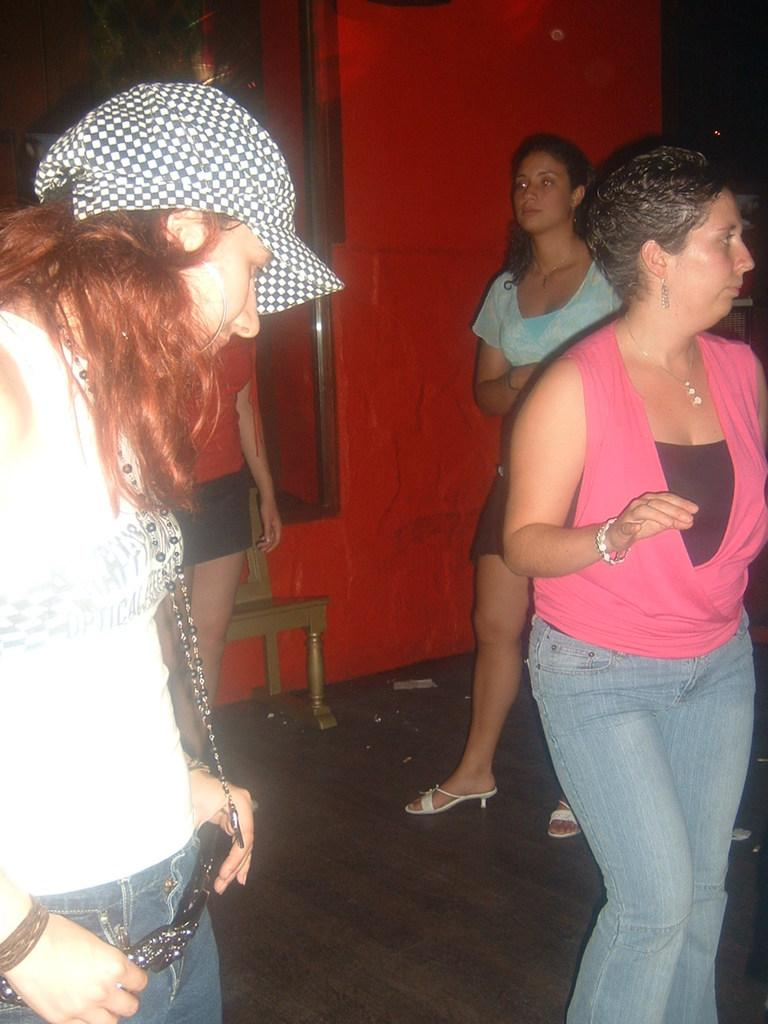How many women are present in the image? There are many women in the image. Where are the women located in the image? The women are standing in a room. What is at the bottom of the image? There is a floor at the bottom of the image. What color is the wall in the background of the image? There is a red-colored wall in the background of the image. What piece of furniture can be seen in the middle of the image? There is a chair in the middle of the image. How does the worm contribute to the quiet atmosphere in the image? There are no worms present in the image, and therefore no such contribution can be observed. 